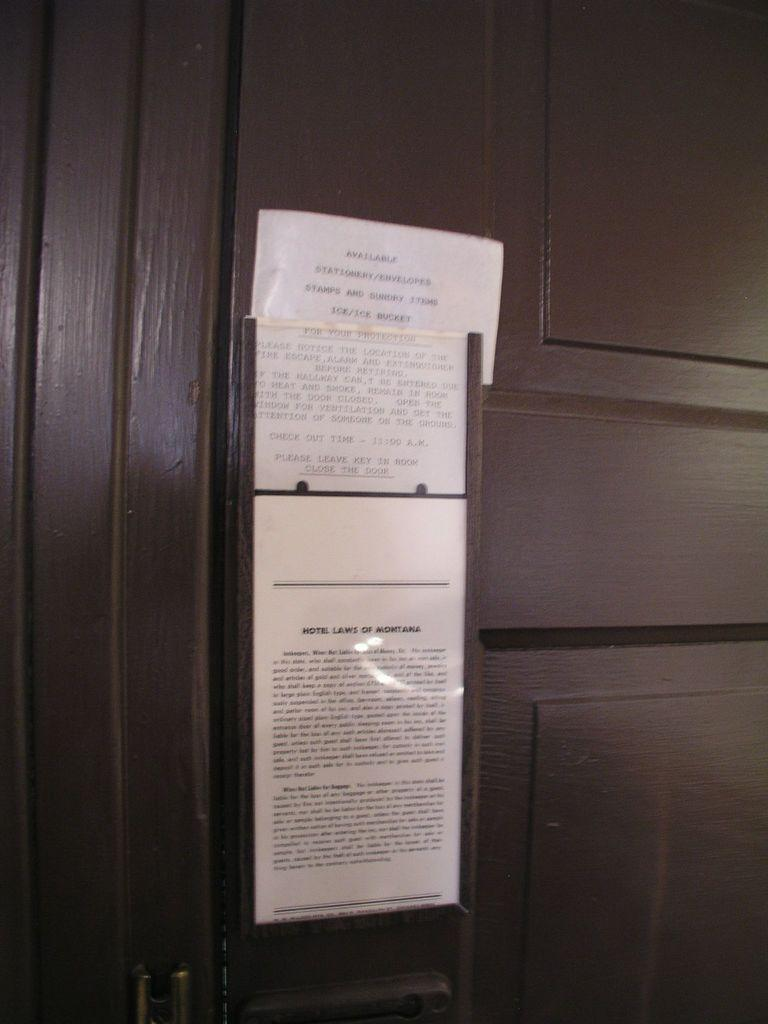<image>
Give a short and clear explanation of the subsequent image. a paper on a door that says 'hotel laws of montana' 